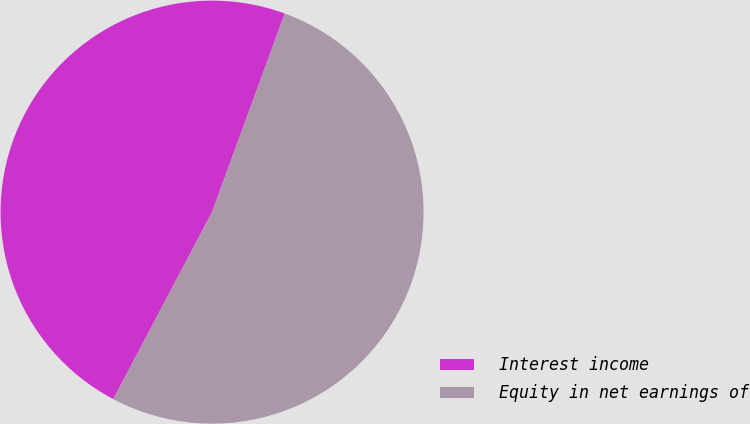<chart> <loc_0><loc_0><loc_500><loc_500><pie_chart><fcel>Interest income<fcel>Equity in net earnings of<nl><fcel>47.85%<fcel>52.15%<nl></chart> 